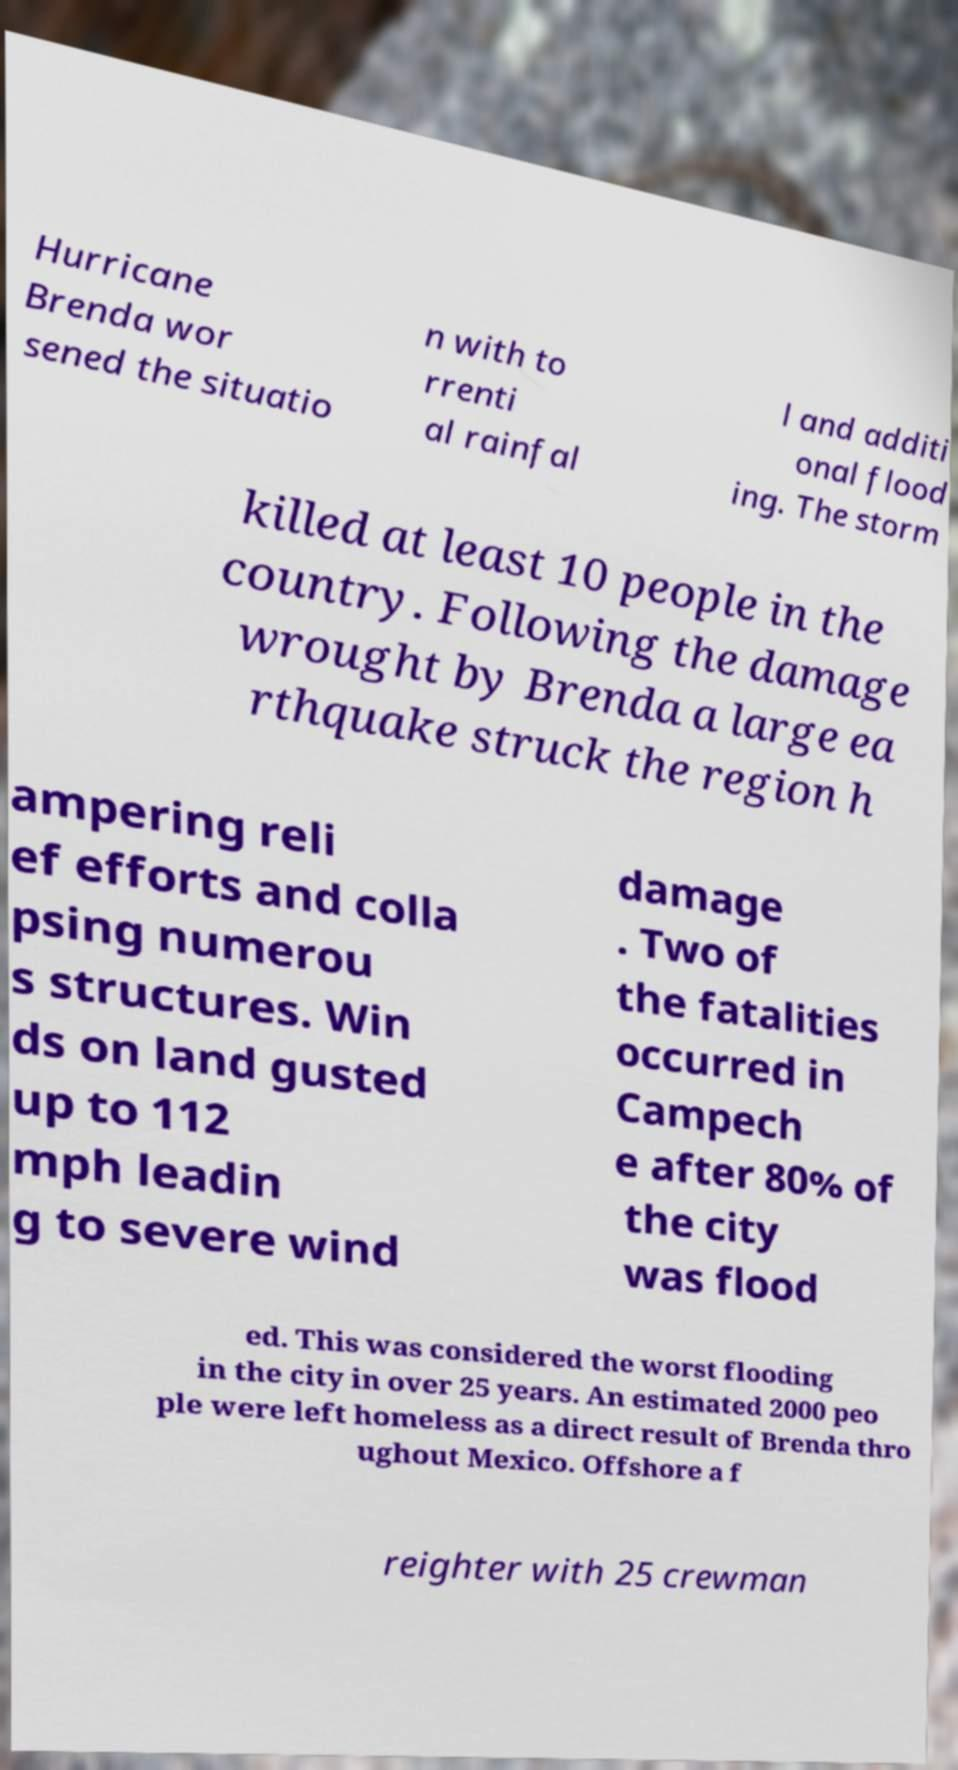What messages or text are displayed in this image? I need them in a readable, typed format. Hurricane Brenda wor sened the situatio n with to rrenti al rainfal l and additi onal flood ing. The storm killed at least 10 people in the country. Following the damage wrought by Brenda a large ea rthquake struck the region h ampering reli ef efforts and colla psing numerou s structures. Win ds on land gusted up to 112 mph leadin g to severe wind damage . Two of the fatalities occurred in Campech e after 80% of the city was flood ed. This was considered the worst flooding in the city in over 25 years. An estimated 2000 peo ple were left homeless as a direct result of Brenda thro ughout Mexico. Offshore a f reighter with 25 crewman 